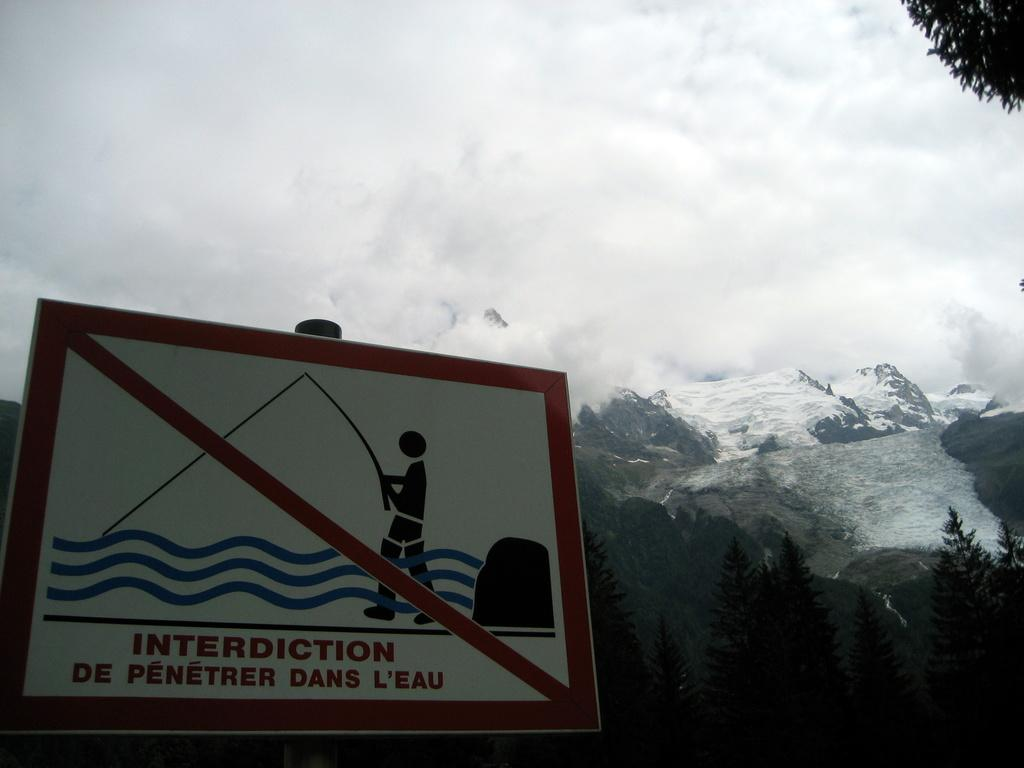<image>
Render a clear and concise summary of the photo. A warning sign for no fishing in a different language that is written interdiction de penetrer dans l'eau. 